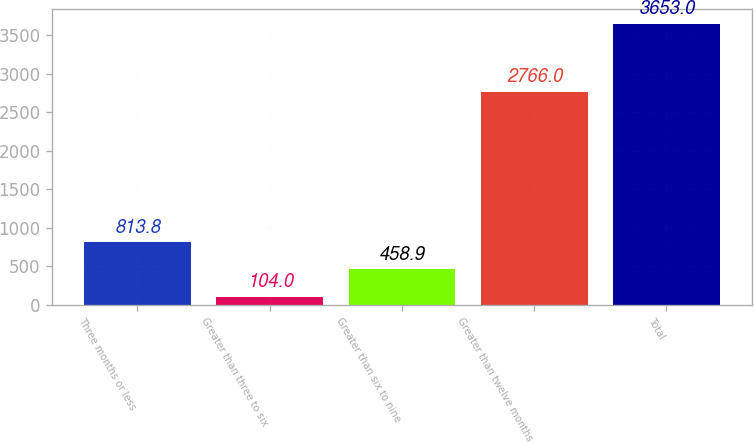Convert chart. <chart><loc_0><loc_0><loc_500><loc_500><bar_chart><fcel>Three months or less<fcel>Greater than three to six<fcel>Greater than six to nine<fcel>Greater than twelve months<fcel>Total<nl><fcel>813.8<fcel>104<fcel>458.9<fcel>2766<fcel>3653<nl></chart> 